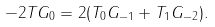Convert formula to latex. <formula><loc_0><loc_0><loc_500><loc_500>- 2 T G _ { 0 } = 2 ( T _ { 0 } G _ { - 1 } + T _ { 1 } G _ { - 2 } ) .</formula> 